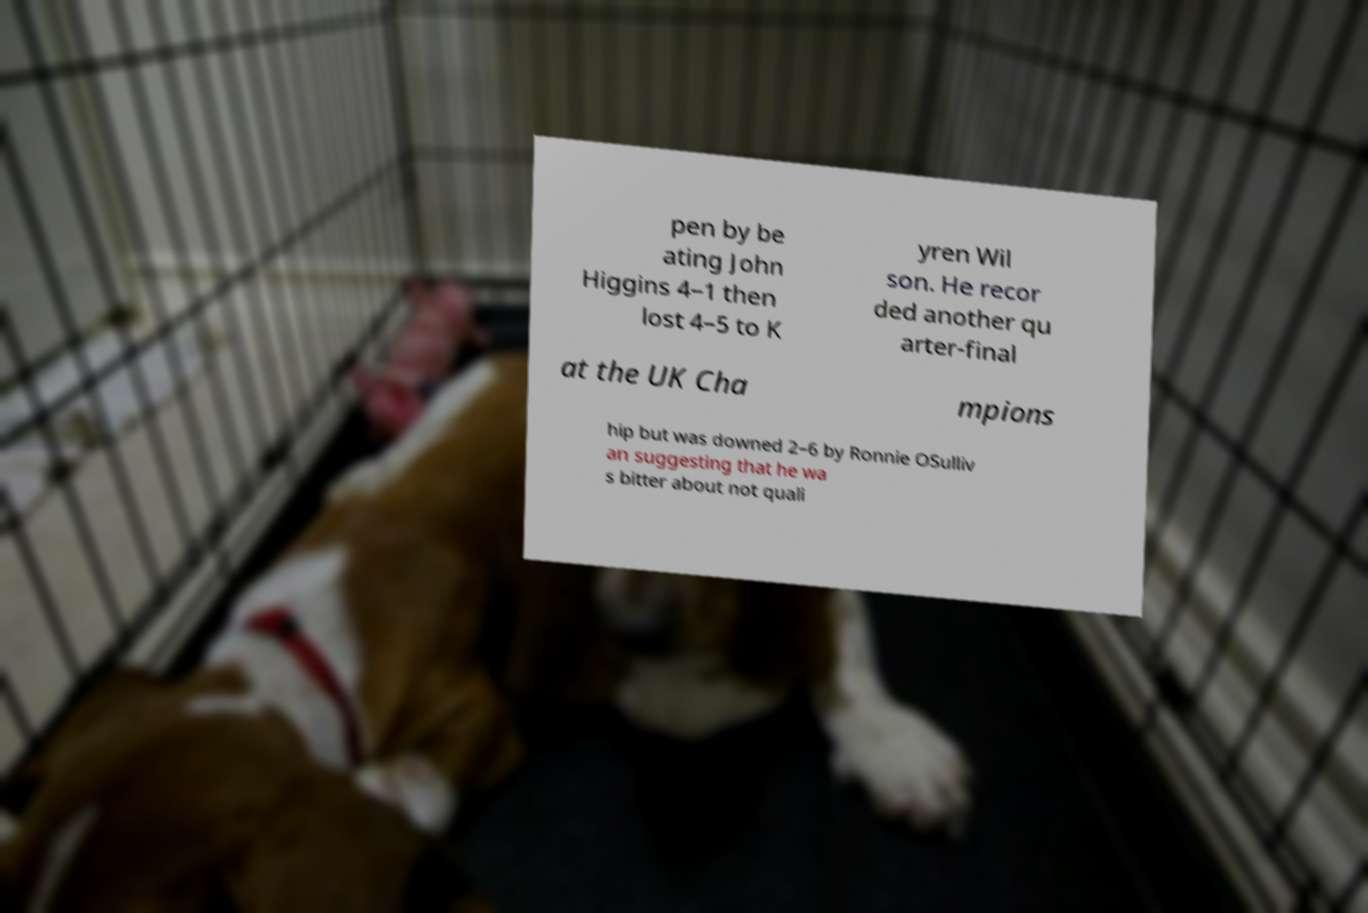Please identify and transcribe the text found in this image. pen by be ating John Higgins 4–1 then lost 4–5 to K yren Wil son. He recor ded another qu arter-final at the UK Cha mpions hip but was downed 2–6 by Ronnie OSulliv an suggesting that he wa s bitter about not quali 